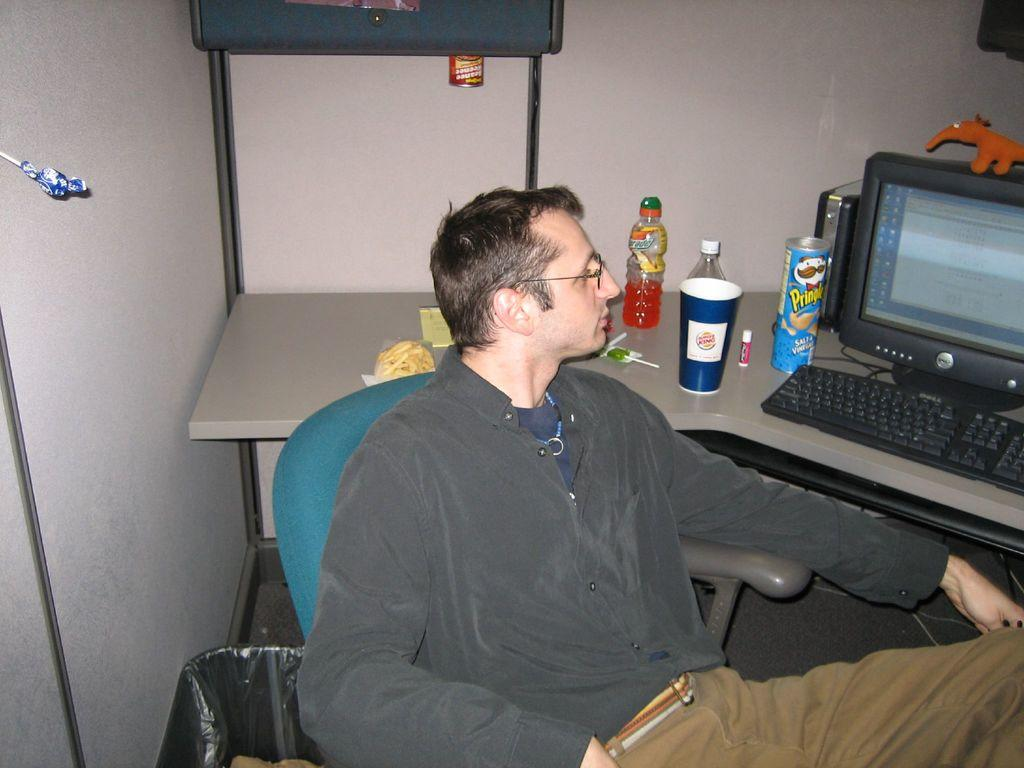<image>
Render a clear and concise summary of the photo. A man sits at a desk with a package of Pringles chips nearby. 